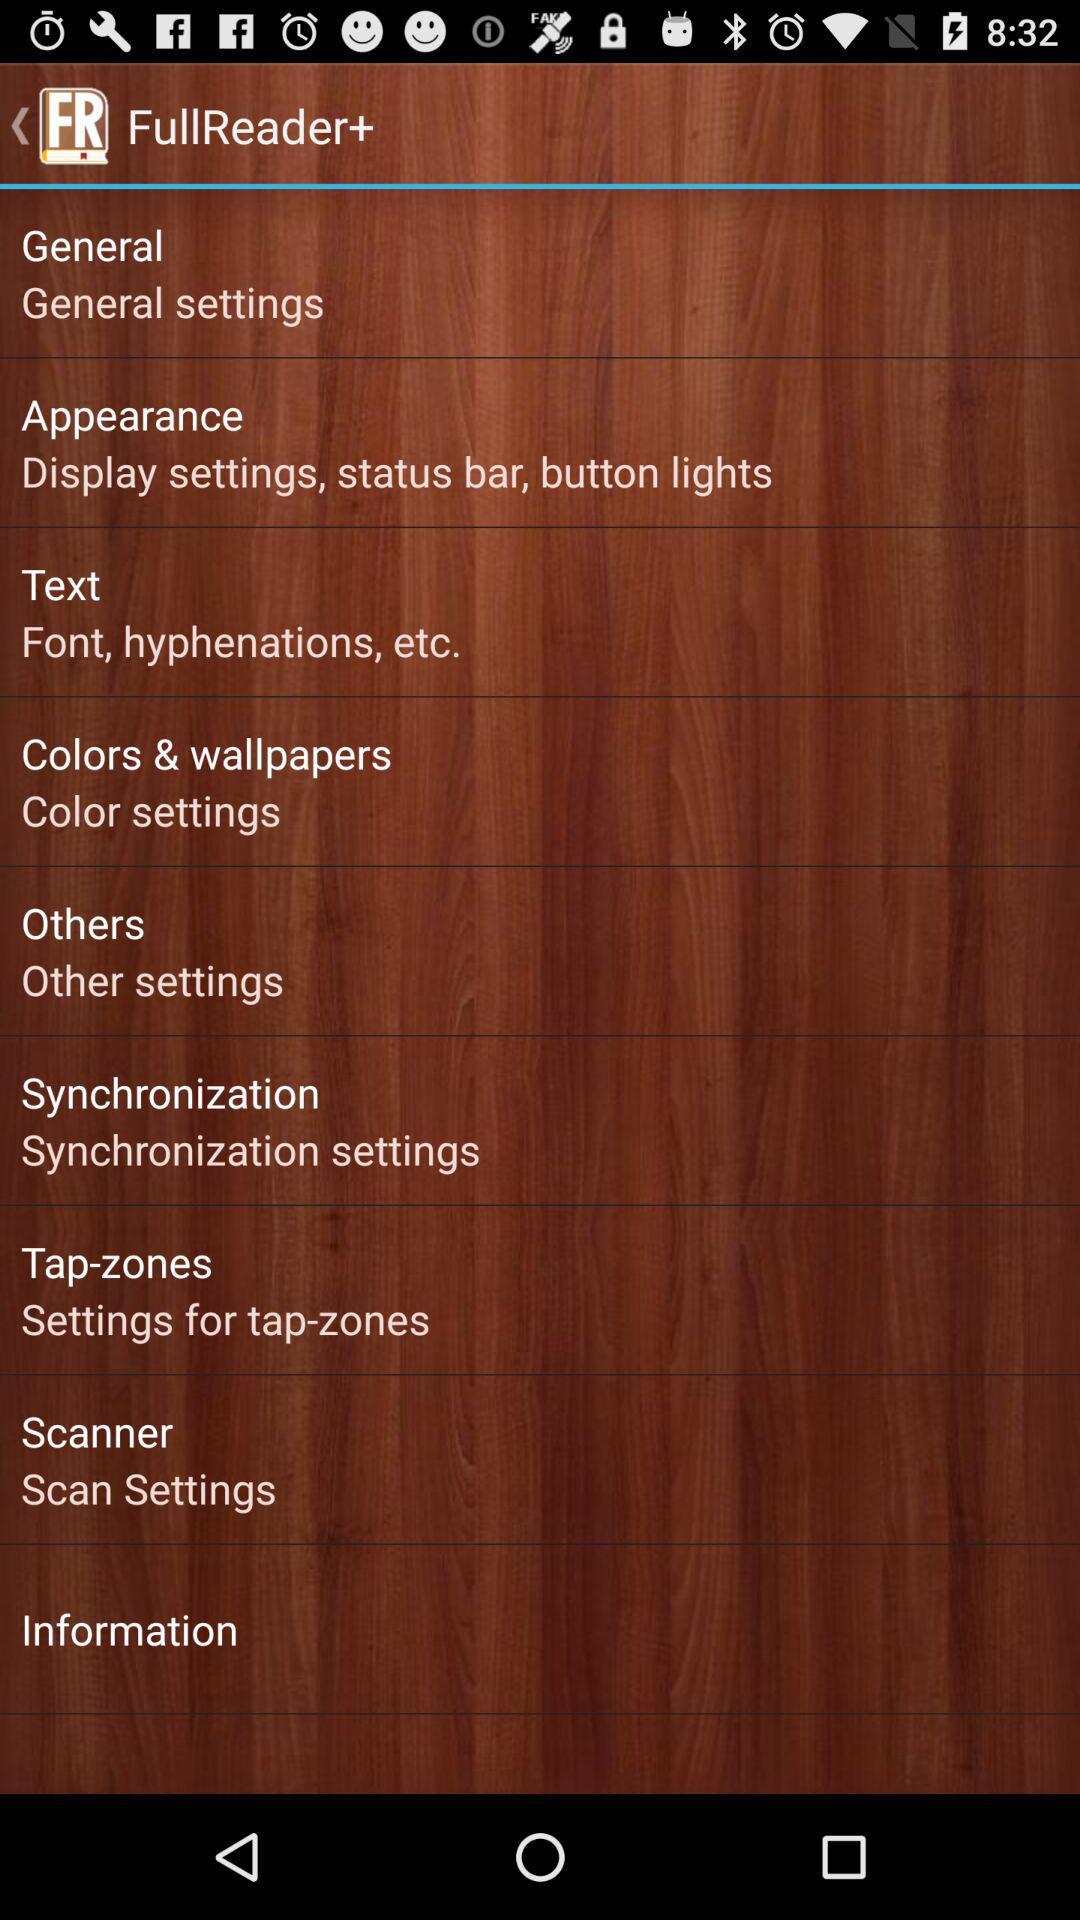How many settings are there in the 'Appearance' section?
Answer the question using a single word or phrase. 3 